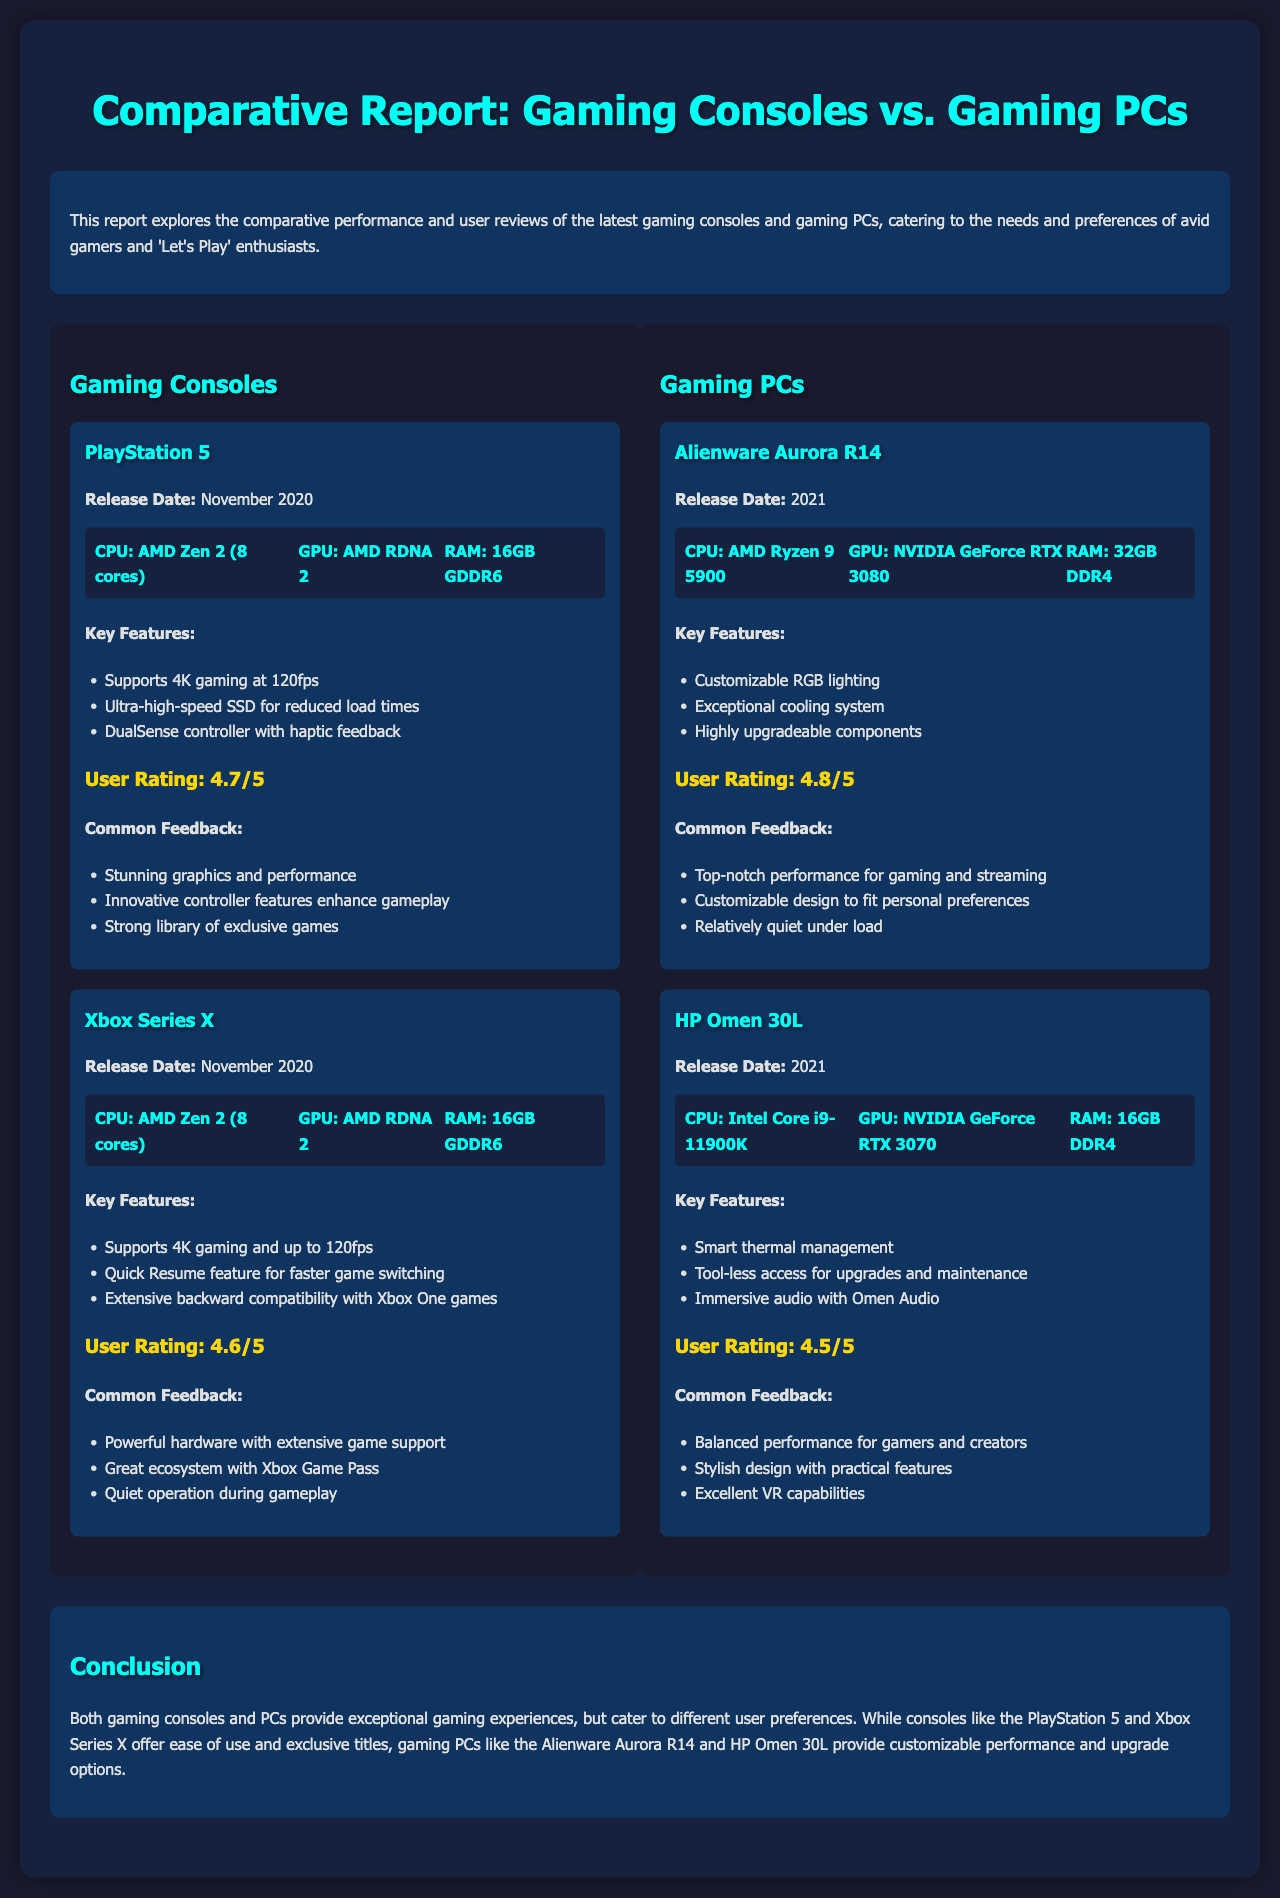what is the user rating of PlayStation 5? The user rating for PlayStation 5 is provided in the document, which is 4.7 out of 5.
Answer: 4.7/5 what are the key features of the Xbox Series X? The document lists key features for the Xbox Series X, including supports for 4K gaming and up to 120fps, Quick Resume, and extensive backward compatibility.
Answer: Supports 4K gaming and up to 120fps, Quick Resume, extensive backward compatibility what is the release date of the Alienware Aurora R14? The release date of the Alienware Aurora R14 is found in the document as 2021.
Answer: 2021 which gaming PC has the highest user rating? The document provides user ratings for the gaming PCs, indicating that the Alienware Aurora R14 has the highest rating at 4.8 out of 5.
Answer: 4.8/5 what unique feature does the DualSense controller offer? The document highlights the unique feature of the DualSense controller, which provides haptic feedback for enhanced gameplay experience.
Answer: Haptic feedback what is the main conclusion of the report? The conclusion summarizes that both gaming consoles and PCs provide exceptional gaming experiences but cater to different user preferences.
Answer: Different user preferences how many cores does the CPU of the PlayStation 5 have? The document mentions that the CPU of the PlayStation 5 consists of 8 cores.
Answer: 8 cores which gaming console is known for its strong library of exclusive games? The document points out that the PlayStation 5 is recognized for its strong library of exclusive games.
Answer: PlayStation 5 what is the RAM amount of the HP Omen 30L? The document specifies that the HP Omen 30L has 16GB of RAM.
Answer: 16GB 